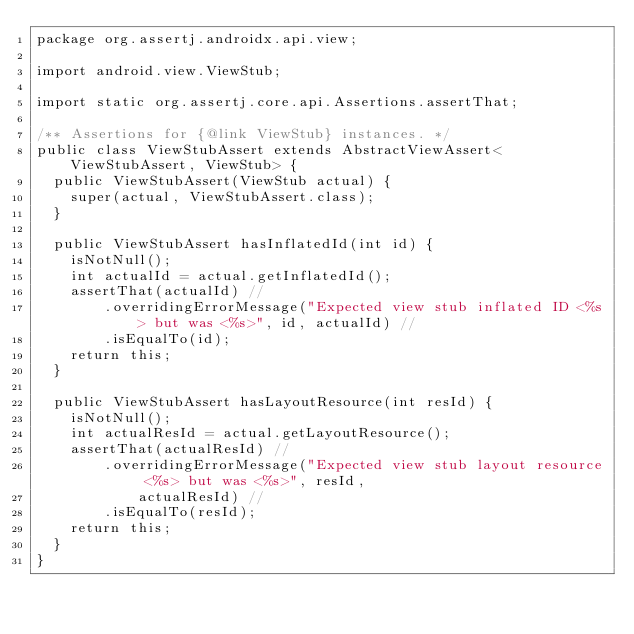<code> <loc_0><loc_0><loc_500><loc_500><_Java_>package org.assertj.androidx.api.view;

import android.view.ViewStub;

import static org.assertj.core.api.Assertions.assertThat;

/** Assertions for {@link ViewStub} instances. */
public class ViewStubAssert extends AbstractViewAssert<ViewStubAssert, ViewStub> {
  public ViewStubAssert(ViewStub actual) {
    super(actual, ViewStubAssert.class);
  }

  public ViewStubAssert hasInflatedId(int id) {
    isNotNull();
    int actualId = actual.getInflatedId();
    assertThat(actualId) //
        .overridingErrorMessage("Expected view stub inflated ID <%s> but was <%s>", id, actualId) //
        .isEqualTo(id);
    return this;
  }

  public ViewStubAssert hasLayoutResource(int resId) {
    isNotNull();
    int actualResId = actual.getLayoutResource();
    assertThat(actualResId) //
        .overridingErrorMessage("Expected view stub layout resource <%s> but was <%s>", resId,
            actualResId) //
        .isEqualTo(resId);
    return this;
  }
}
</code> 